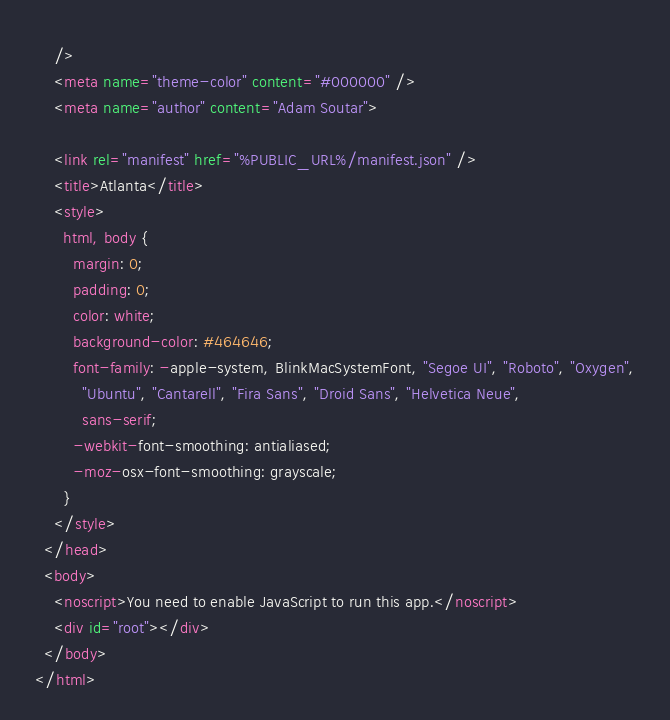Convert code to text. <code><loc_0><loc_0><loc_500><loc_500><_HTML_>    />
    <meta name="theme-color" content="#000000" />
    <meta name="author" content="Adam Soutar">

    <link rel="manifest" href="%PUBLIC_URL%/manifest.json" />
    <title>Atlanta</title>
    <style>
      html, body {
        margin: 0;
        padding: 0;
        color: white;
        background-color: #464646;
        font-family: -apple-system, BlinkMacSystemFont, "Segoe UI", "Roboto", "Oxygen",
          "Ubuntu", "Cantarell", "Fira Sans", "Droid Sans", "Helvetica Neue",
          sans-serif;
        -webkit-font-smoothing: antialiased;
        -moz-osx-font-smoothing: grayscale;
      }
    </style>
  </head>
  <body>
    <noscript>You need to enable JavaScript to run this app.</noscript>
    <div id="root"></div>
  </body>
</html>
</code> 